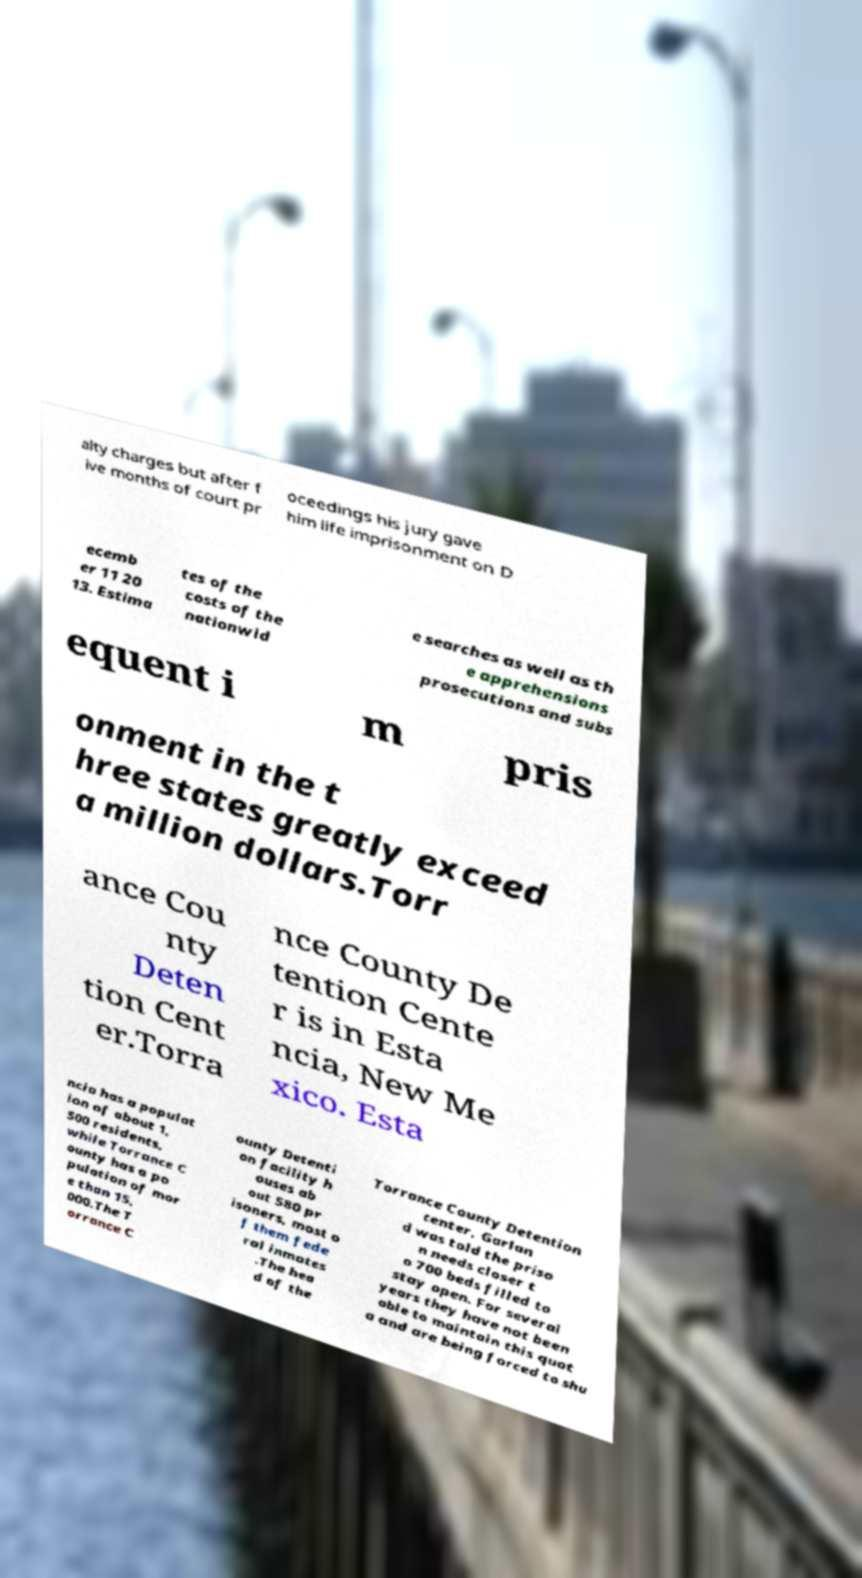Can you read and provide the text displayed in the image?This photo seems to have some interesting text. Can you extract and type it out for me? alty charges but after f ive months of court pr oceedings his jury gave him life imprisonment on D ecemb er 11 20 13. Estima tes of the costs of the nationwid e searches as well as th e apprehensions prosecutions and subs equent i m pris onment in the t hree states greatly exceed a million dollars.Torr ance Cou nty Deten tion Cent er.Torra nce County De tention Cente r is in Esta ncia, New Me xico. Esta ncia has a populat ion of about 1, 500 residents, while Torrance C ounty has a po pulation of mor e than 15, 000.The T orrance C ounty Detenti on facility h ouses ab out 580 pr isoners, most o f them fede ral inmates .The hea d of the Torrance County Detention center, Garlan d was told the priso n needs closer t o 700 beds filled to stay open. For several years they have not been able to maintain this quot a and are being forced to shu 